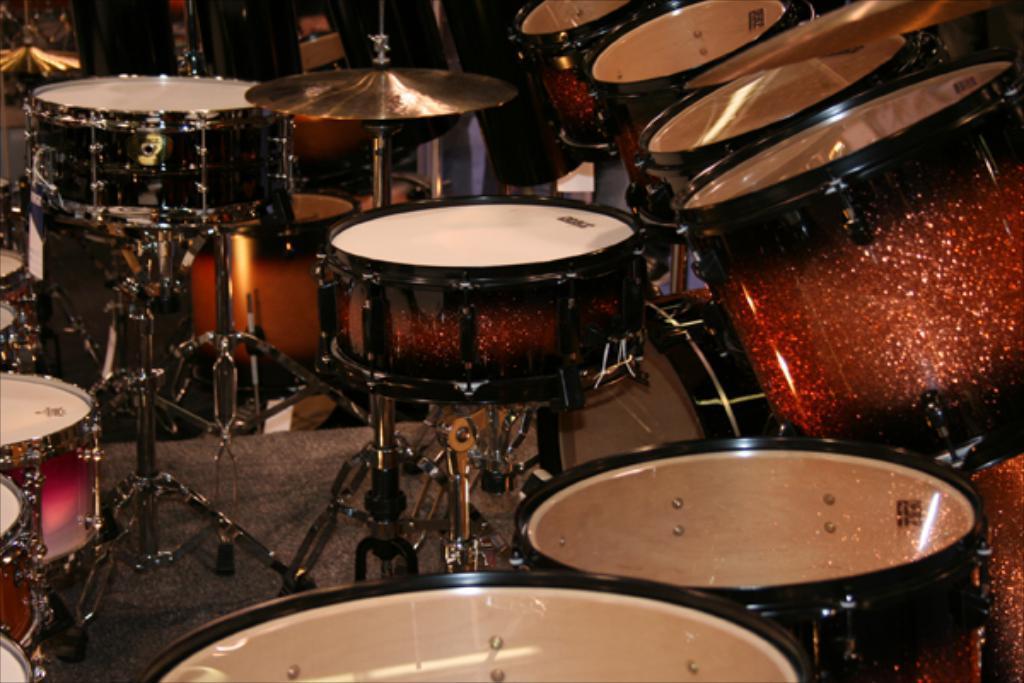Describe this image in one or two sentences. In this image I can see few musical instruments and they are in white, black and brown color. 